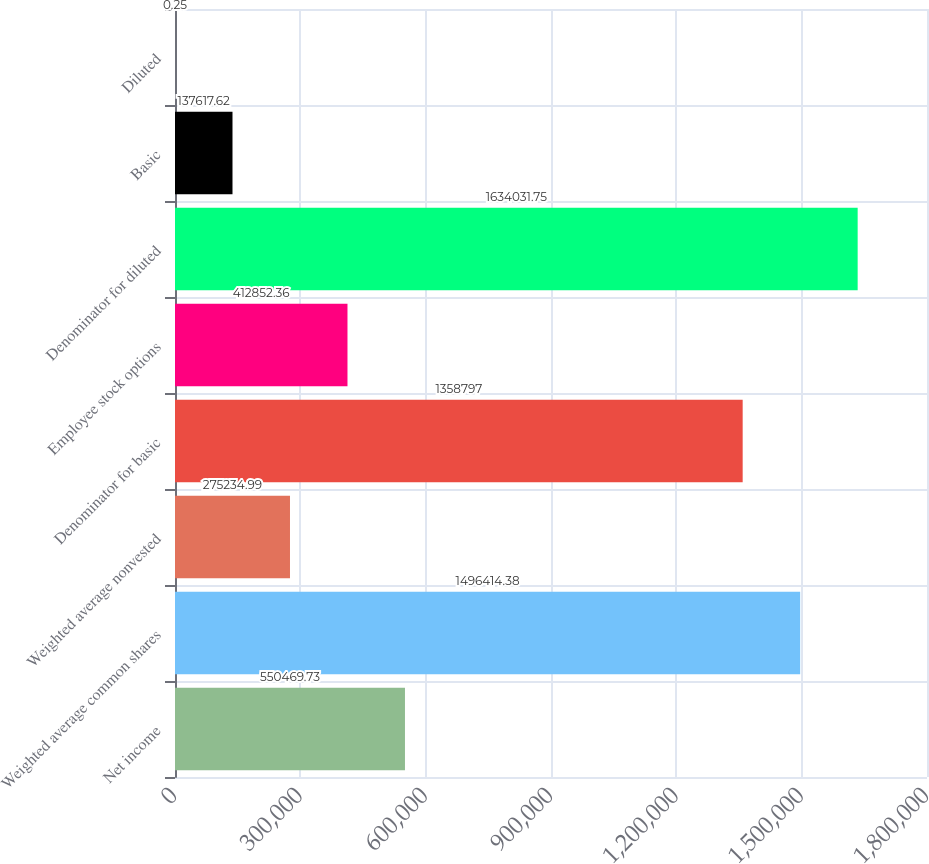<chart> <loc_0><loc_0><loc_500><loc_500><bar_chart><fcel>Net income<fcel>Weighted average common shares<fcel>Weighted average nonvested<fcel>Denominator for basic<fcel>Employee stock options<fcel>Denominator for diluted<fcel>Basic<fcel>Diluted<nl><fcel>550470<fcel>1.49641e+06<fcel>275235<fcel>1.3588e+06<fcel>412852<fcel>1.63403e+06<fcel>137618<fcel>0.25<nl></chart> 